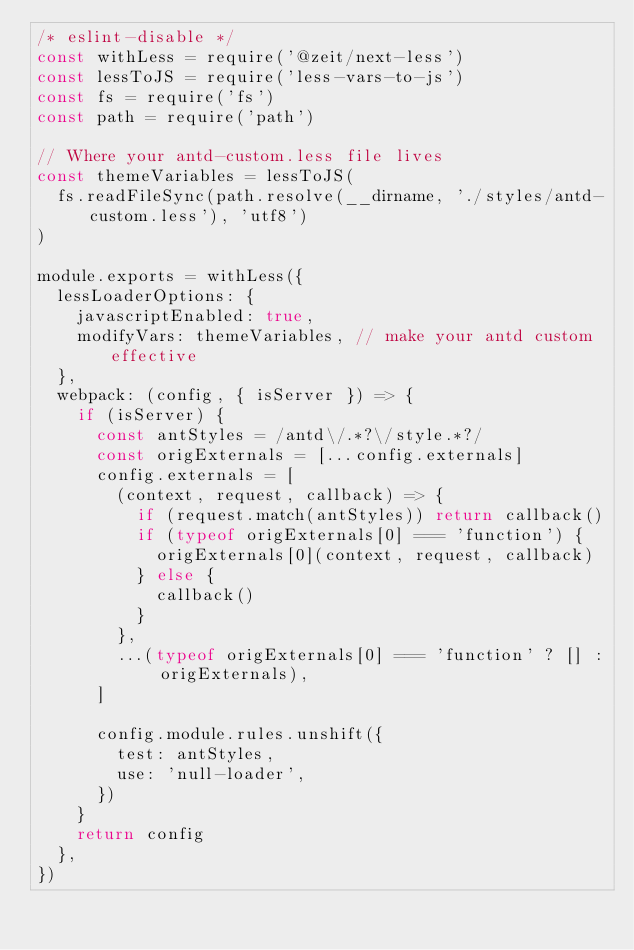<code> <loc_0><loc_0><loc_500><loc_500><_JavaScript_>/* eslint-disable */
const withLess = require('@zeit/next-less')
const lessToJS = require('less-vars-to-js')
const fs = require('fs')
const path = require('path')

// Where your antd-custom.less file lives
const themeVariables = lessToJS(
  fs.readFileSync(path.resolve(__dirname, './styles/antd-custom.less'), 'utf8')
)

module.exports = withLess({
  lessLoaderOptions: {
    javascriptEnabled: true,
    modifyVars: themeVariables, // make your antd custom effective
  },
  webpack: (config, { isServer }) => {
    if (isServer) {
      const antStyles = /antd\/.*?\/style.*?/
      const origExternals = [...config.externals]
      config.externals = [
        (context, request, callback) => {
          if (request.match(antStyles)) return callback()
          if (typeof origExternals[0] === 'function') {
            origExternals[0](context, request, callback)
          } else {
            callback()
          }
        },
        ...(typeof origExternals[0] === 'function' ? [] : origExternals),
      ]

      config.module.rules.unshift({
        test: antStyles,
        use: 'null-loader',
      })
    }
    return config
  },
})
</code> 